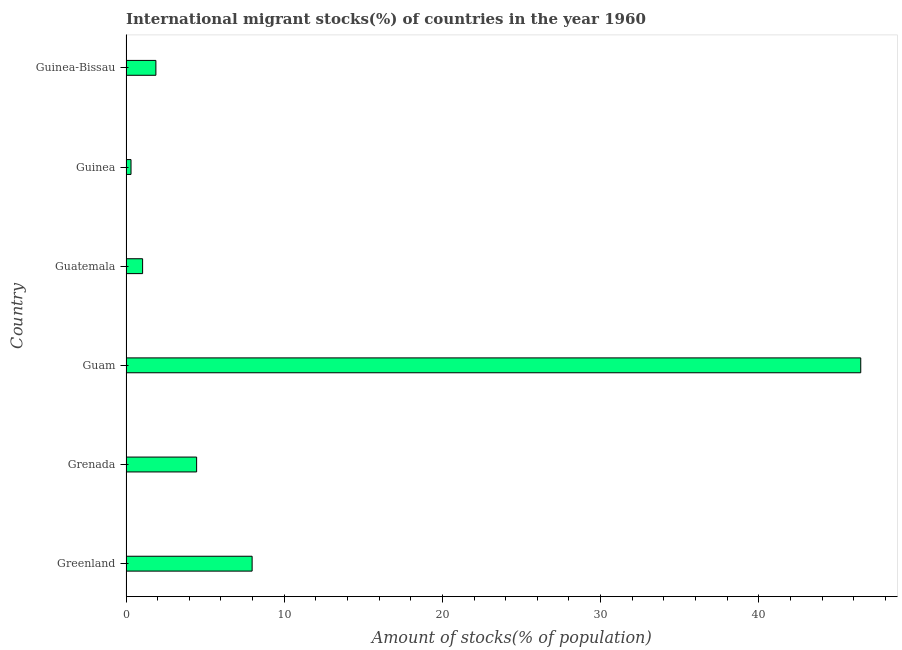Does the graph contain grids?
Make the answer very short. No. What is the title of the graph?
Your response must be concise. International migrant stocks(%) of countries in the year 1960. What is the label or title of the X-axis?
Ensure brevity in your answer.  Amount of stocks(% of population). What is the label or title of the Y-axis?
Offer a terse response. Country. What is the number of international migrant stocks in Grenada?
Provide a succinct answer. 4.46. Across all countries, what is the maximum number of international migrant stocks?
Make the answer very short. 46.45. Across all countries, what is the minimum number of international migrant stocks?
Ensure brevity in your answer.  0.32. In which country was the number of international migrant stocks maximum?
Provide a succinct answer. Guam. In which country was the number of international migrant stocks minimum?
Your answer should be compact. Guinea. What is the sum of the number of international migrant stocks?
Give a very brief answer. 62.14. What is the difference between the number of international migrant stocks in Guatemala and Guinea?
Offer a very short reply. 0.73. What is the average number of international migrant stocks per country?
Keep it short and to the point. 10.36. What is the median number of international migrant stocks?
Provide a short and direct response. 3.18. What is the ratio of the number of international migrant stocks in Guam to that in Guatemala?
Provide a succinct answer. 44.27. What is the difference between the highest and the second highest number of international migrant stocks?
Provide a short and direct response. 38.48. Is the sum of the number of international migrant stocks in Guam and Guinea-Bissau greater than the maximum number of international migrant stocks across all countries?
Keep it short and to the point. Yes. What is the difference between the highest and the lowest number of international migrant stocks?
Keep it short and to the point. 46.13. In how many countries, is the number of international migrant stocks greater than the average number of international migrant stocks taken over all countries?
Keep it short and to the point. 1. How many bars are there?
Offer a terse response. 6. Are all the bars in the graph horizontal?
Your response must be concise. Yes. How many countries are there in the graph?
Your response must be concise. 6. What is the Amount of stocks(% of population) of Greenland?
Offer a very short reply. 7.97. What is the Amount of stocks(% of population) in Grenada?
Make the answer very short. 4.46. What is the Amount of stocks(% of population) of Guam?
Your answer should be compact. 46.45. What is the Amount of stocks(% of population) of Guatemala?
Your response must be concise. 1.05. What is the Amount of stocks(% of population) in Guinea?
Give a very brief answer. 0.32. What is the Amount of stocks(% of population) of Guinea-Bissau?
Give a very brief answer. 1.89. What is the difference between the Amount of stocks(% of population) in Greenland and Grenada?
Your answer should be compact. 3.51. What is the difference between the Amount of stocks(% of population) in Greenland and Guam?
Ensure brevity in your answer.  -38.48. What is the difference between the Amount of stocks(% of population) in Greenland and Guatemala?
Keep it short and to the point. 6.92. What is the difference between the Amount of stocks(% of population) in Greenland and Guinea?
Keep it short and to the point. 7.66. What is the difference between the Amount of stocks(% of population) in Greenland and Guinea-Bissau?
Keep it short and to the point. 6.08. What is the difference between the Amount of stocks(% of population) in Grenada and Guam?
Ensure brevity in your answer.  -41.99. What is the difference between the Amount of stocks(% of population) in Grenada and Guatemala?
Your response must be concise. 3.41. What is the difference between the Amount of stocks(% of population) in Grenada and Guinea?
Your response must be concise. 4.15. What is the difference between the Amount of stocks(% of population) in Grenada and Guinea-Bissau?
Ensure brevity in your answer.  2.57. What is the difference between the Amount of stocks(% of population) in Guam and Guatemala?
Your response must be concise. 45.4. What is the difference between the Amount of stocks(% of population) in Guam and Guinea?
Provide a succinct answer. 46.13. What is the difference between the Amount of stocks(% of population) in Guam and Guinea-Bissau?
Offer a very short reply. 44.56. What is the difference between the Amount of stocks(% of population) in Guatemala and Guinea?
Your answer should be very brief. 0.73. What is the difference between the Amount of stocks(% of population) in Guatemala and Guinea-Bissau?
Offer a terse response. -0.84. What is the difference between the Amount of stocks(% of population) in Guinea and Guinea-Bissau?
Your answer should be very brief. -1.57. What is the ratio of the Amount of stocks(% of population) in Greenland to that in Grenada?
Your answer should be compact. 1.79. What is the ratio of the Amount of stocks(% of population) in Greenland to that in Guam?
Keep it short and to the point. 0.17. What is the ratio of the Amount of stocks(% of population) in Greenland to that in Guatemala?
Make the answer very short. 7.6. What is the ratio of the Amount of stocks(% of population) in Greenland to that in Guinea?
Keep it short and to the point. 25.21. What is the ratio of the Amount of stocks(% of population) in Greenland to that in Guinea-Bissau?
Ensure brevity in your answer.  4.22. What is the ratio of the Amount of stocks(% of population) in Grenada to that in Guam?
Keep it short and to the point. 0.1. What is the ratio of the Amount of stocks(% of population) in Grenada to that in Guatemala?
Your answer should be very brief. 4.25. What is the ratio of the Amount of stocks(% of population) in Grenada to that in Guinea?
Ensure brevity in your answer.  14.12. What is the ratio of the Amount of stocks(% of population) in Grenada to that in Guinea-Bissau?
Offer a terse response. 2.36. What is the ratio of the Amount of stocks(% of population) in Guam to that in Guatemala?
Your response must be concise. 44.27. What is the ratio of the Amount of stocks(% of population) in Guam to that in Guinea?
Make the answer very short. 146.88. What is the ratio of the Amount of stocks(% of population) in Guam to that in Guinea-Bissau?
Ensure brevity in your answer.  24.59. What is the ratio of the Amount of stocks(% of population) in Guatemala to that in Guinea?
Provide a short and direct response. 3.32. What is the ratio of the Amount of stocks(% of population) in Guatemala to that in Guinea-Bissau?
Offer a terse response. 0.56. What is the ratio of the Amount of stocks(% of population) in Guinea to that in Guinea-Bissau?
Offer a very short reply. 0.17. 